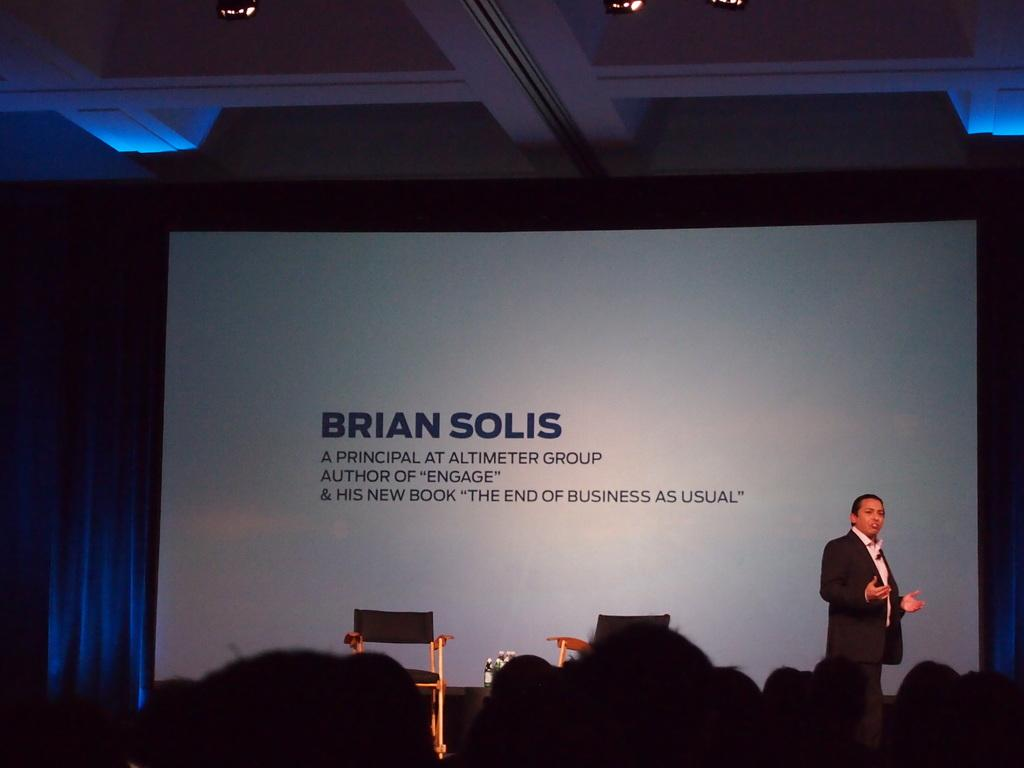What is the main object in the image? There is a screen in the image. What can be seen behind the screen? There is a blue color curtain in the image. Are there any people in the image? Yes, there are people present in the image. What type of furniture is visible in the image? A chair is visible in the image. What is the person standing wearing? The person standing is wearing a blue color jacket. What type of class is being taught in the image? There is no indication of a class being taught in the image. 